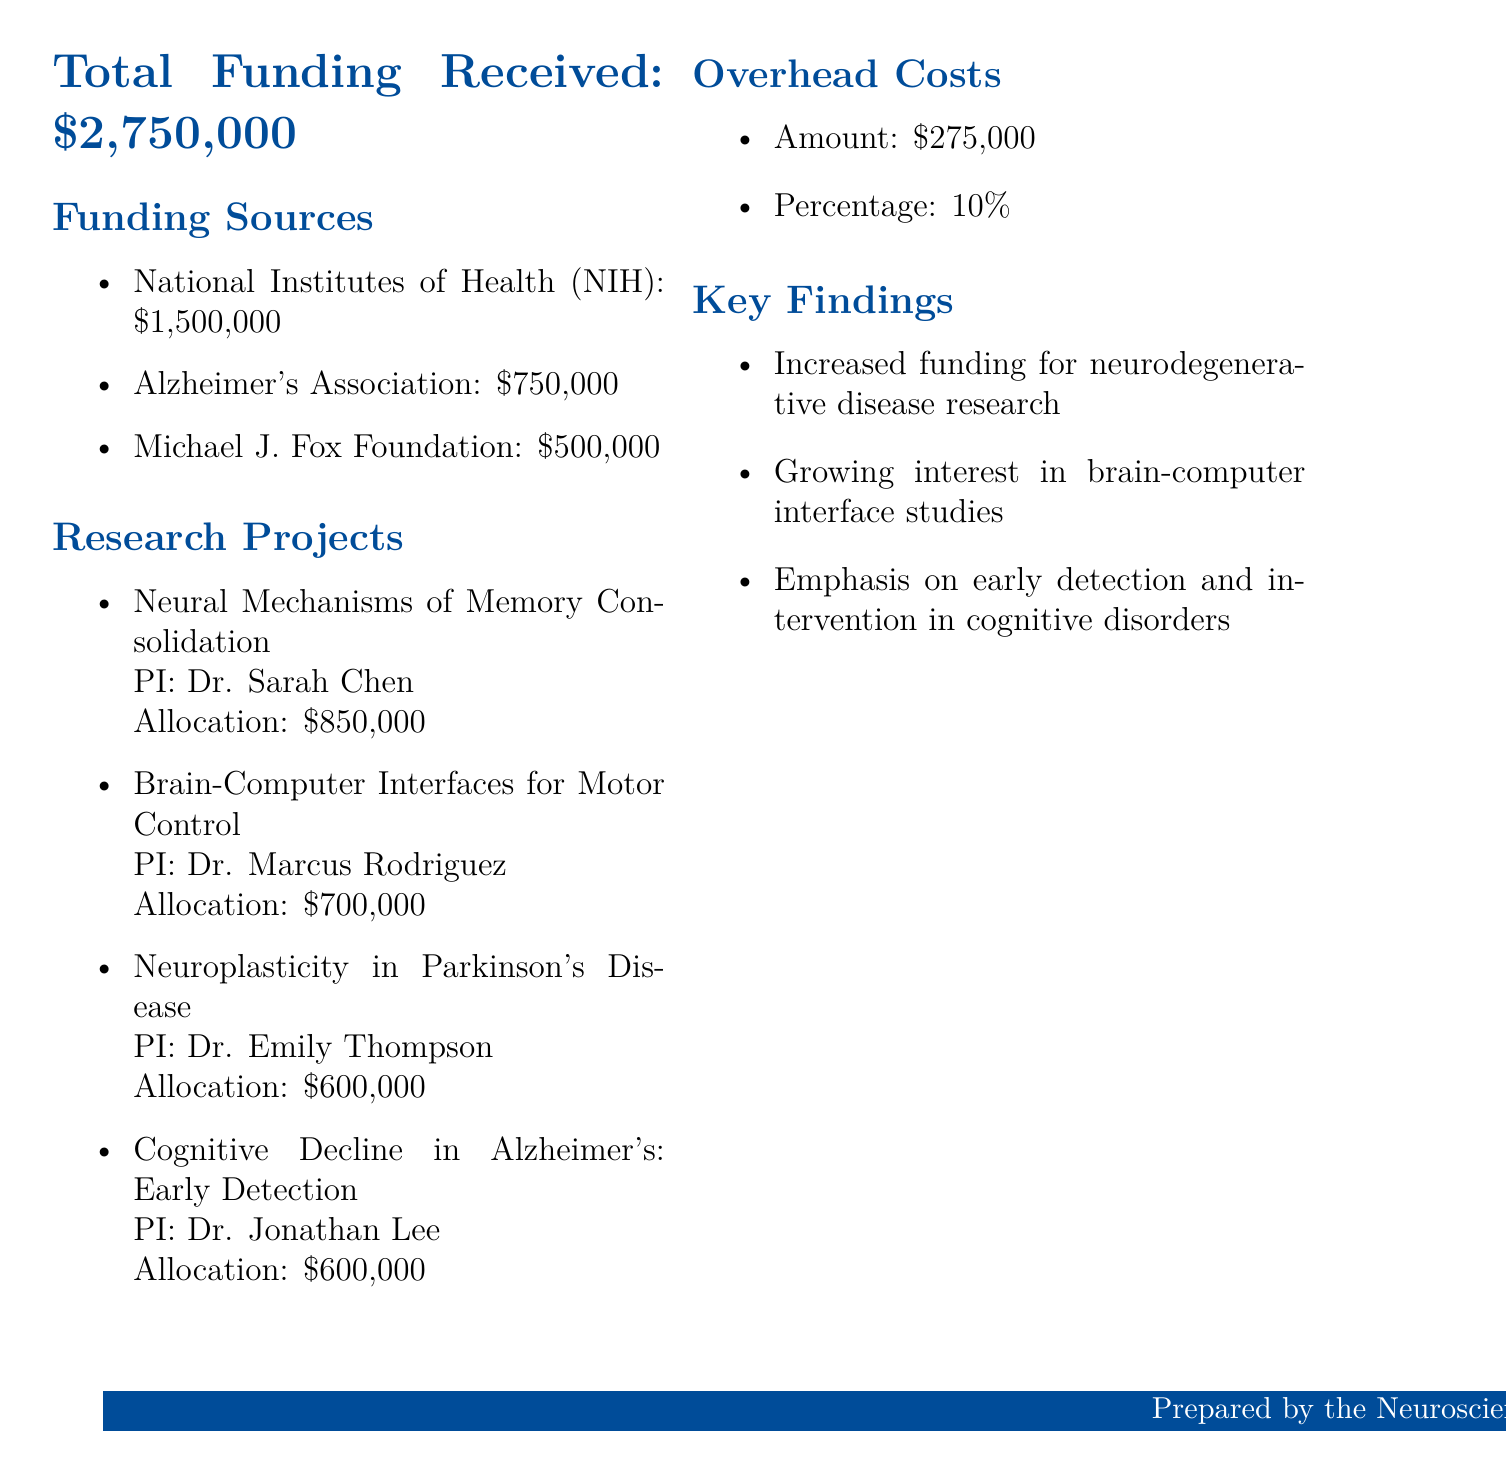What is the total funding received? The total funding received is specified as $2,750,000.
Answer: $2,750,000 Who is the principal investigator for the "Neuroplasticity in Parkinson's Disease" project? The document lists Dr. Emily Thompson as the principal investigator for this project.
Answer: Dr. Emily Thompson What percentage do overhead costs represent? The document specifies that overhead costs are 10% of the total funding received.
Answer: 10% How much funding is allocated to the project titled "Cognitive Decline in Alzheimer's: Early Detection"? The allocation for this project is stated to be $600,000.
Answer: $600,000 Which funding source contributed the most? The document indicates that the National Institutes of Health (NIH) contributed the highest amount of $1,500,000.
Answer: National Institutes of Health (NIH) What is one key finding mentioned in the report? The document includes "Increased funding for neurodegenerative disease research" as one of the key findings.
Answer: Increased funding for neurodegenerative disease research How many research projects received funding? The document lists four research projects that received funding.
Answer: Four What is the amount allocated to the project "Brain-Computer Interfaces for Motor Control"? The allocation for this project is specified as $700,000.
Answer: $700,000 What funding source contributed $500,000? The document notes that the Michael J. Fox Foundation contributed this amount.
Answer: Michael J. Fox Foundation 